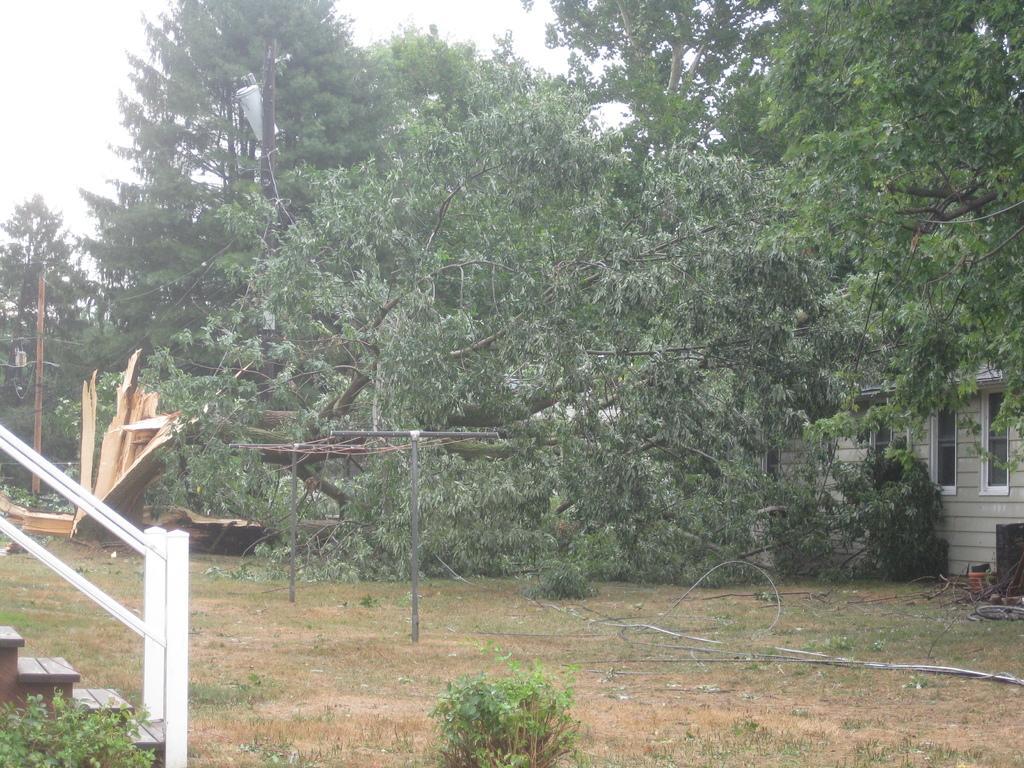Can you describe this image briefly? In the image there is a land, stairs, house and money trees. 